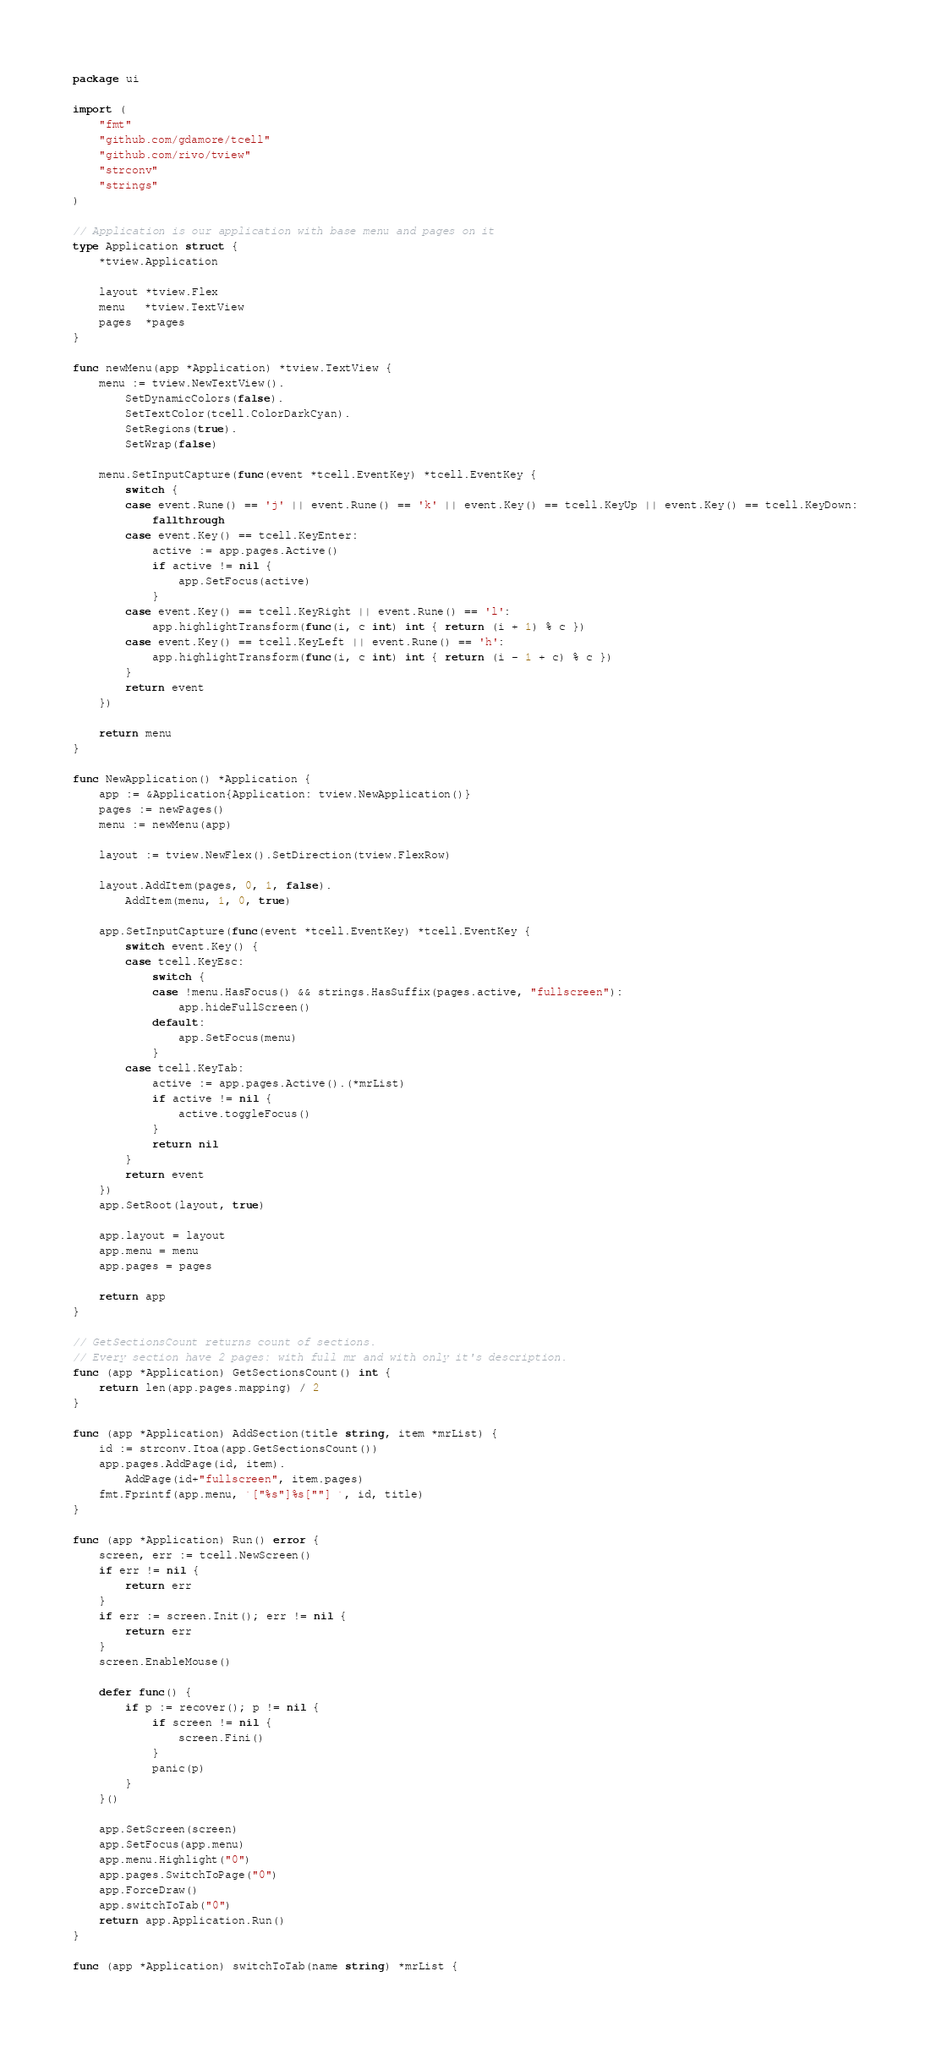<code> <loc_0><loc_0><loc_500><loc_500><_Go_>package ui

import (
	"fmt"
	"github.com/gdamore/tcell"
	"github.com/rivo/tview"
	"strconv"
	"strings"
)

// Application is our application with base menu and pages on it
type Application struct {
	*tview.Application

	layout *tview.Flex
	menu   *tview.TextView
	pages  *pages
}

func newMenu(app *Application) *tview.TextView {
	menu := tview.NewTextView().
		SetDynamicColors(false).
		SetTextColor(tcell.ColorDarkCyan).
		SetRegions(true).
		SetWrap(false)

	menu.SetInputCapture(func(event *tcell.EventKey) *tcell.EventKey {
		switch {
		case event.Rune() == 'j' || event.Rune() == 'k' || event.Key() == tcell.KeyUp || event.Key() == tcell.KeyDown:
			fallthrough
		case event.Key() == tcell.KeyEnter:
			active := app.pages.Active()
			if active != nil {
				app.SetFocus(active)
			}
		case event.Key() == tcell.KeyRight || event.Rune() == 'l':
			app.highlightTransform(func(i, c int) int { return (i + 1) % c })
		case event.Key() == tcell.KeyLeft || event.Rune() == 'h':
			app.highlightTransform(func(i, c int) int { return (i - 1 + c) % c })
		}
		return event
	})

	return menu
}

func NewApplication() *Application {
	app := &Application{Application: tview.NewApplication()}
	pages := newPages()
	menu := newMenu(app)

	layout := tview.NewFlex().SetDirection(tview.FlexRow)

	layout.AddItem(pages, 0, 1, false).
		AddItem(menu, 1, 0, true)

	app.SetInputCapture(func(event *tcell.EventKey) *tcell.EventKey {
		switch event.Key() {
		case tcell.KeyEsc:
			switch {
			case !menu.HasFocus() && strings.HasSuffix(pages.active, "fullscreen"):
				app.hideFullScreen()
			default:
				app.SetFocus(menu)
			}
		case tcell.KeyTab:
			active := app.pages.Active().(*mrList)
			if active != nil {
				active.toggleFocus()
			}
			return nil
		}
		return event
	})
	app.SetRoot(layout, true)

	app.layout = layout
	app.menu = menu
	app.pages = pages

	return app
}

// GetSectionsCount returns count of sections.
// Every section have 2 pages: with full mr and with only it's description.
func (app *Application) GetSectionsCount() int {
	return len(app.pages.mapping) / 2
}

func (app *Application) AddSection(title string, item *mrList) {
	id := strconv.Itoa(app.GetSectionsCount())
	app.pages.AddPage(id, item).
		AddPage(id+"fullscreen", item.pages)
	fmt.Fprintf(app.menu, `["%s"]%s[""] `, id, title)
}

func (app *Application) Run() error {
	screen, err := tcell.NewScreen()
	if err != nil {
		return err
	}
	if err := screen.Init(); err != nil {
		return err
	}
	screen.EnableMouse()

	defer func() {
		if p := recover(); p != nil {
			if screen != nil {
				screen.Fini()
			}
			panic(p)
		}
	}()

	app.SetScreen(screen)
	app.SetFocus(app.menu)
	app.menu.Highlight("0")
	app.pages.SwitchToPage("0")
	app.ForceDraw()
	app.switchToTab("0")
	return app.Application.Run()
}

func (app *Application) switchToTab(name string) *mrList {</code> 